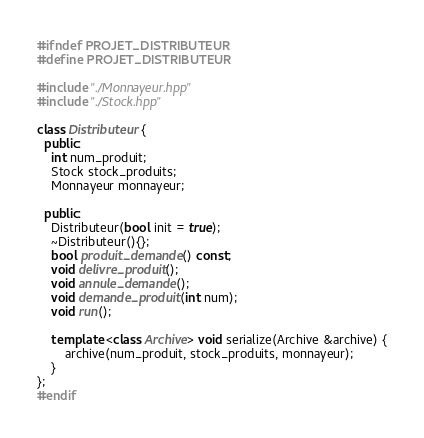Convert code to text. <code><loc_0><loc_0><loc_500><loc_500><_C++_>#ifndef PROJET_DISTRIBUTEUR
#define PROJET_DISTRIBUTEUR

#include "./Monnayeur.hpp"
#include "./Stock.hpp"

class Distributeur {
  public:
	int num_produit;
	Stock stock_produits;
	Monnayeur monnayeur;

  public:
	Distributeur(bool init = true);
	~Distributeur(){};
	bool produit_demande() const;
	void delivre_produit();
	void annule_demande();
	void demande_produit(int num);
	void run();

	template <class Archive> void serialize(Archive &archive) {
		archive(num_produit, stock_produits, monnayeur);
	}
};
#endif</code> 